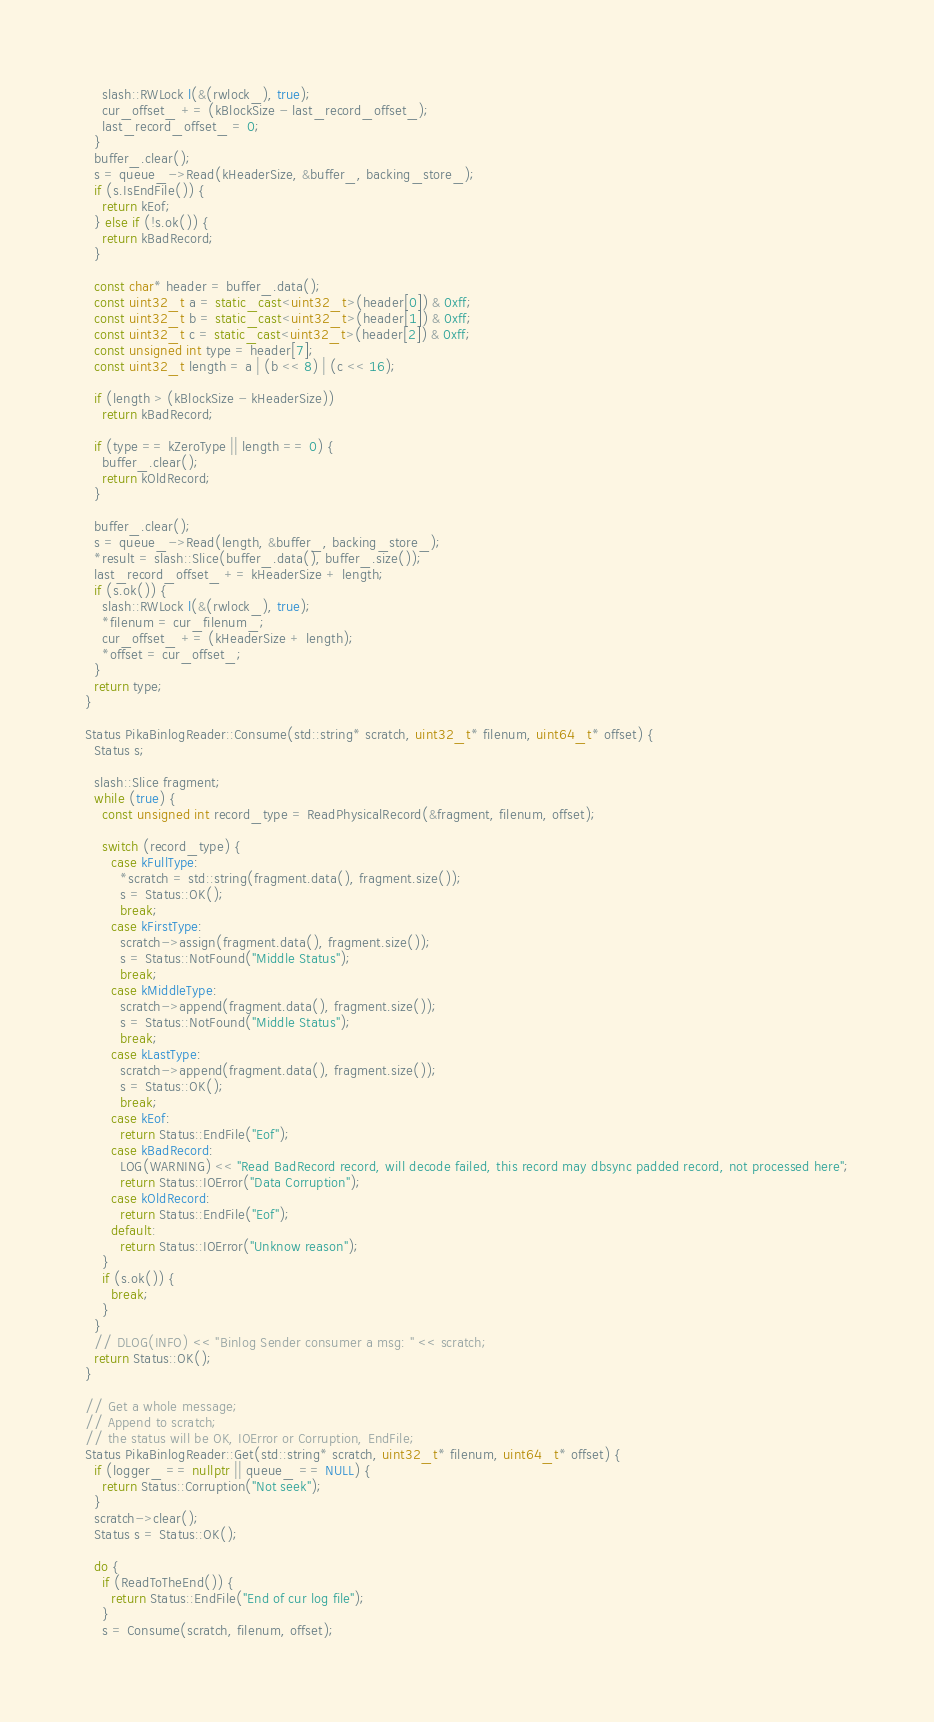<code> <loc_0><loc_0><loc_500><loc_500><_C++_>    slash::RWLock l(&(rwlock_), true);
    cur_offset_ += (kBlockSize - last_record_offset_);
    last_record_offset_ = 0;
  }
  buffer_.clear();
  s = queue_->Read(kHeaderSize, &buffer_, backing_store_);
  if (s.IsEndFile()) {
    return kEof;
  } else if (!s.ok()) {
    return kBadRecord;
  }

  const char* header = buffer_.data();
  const uint32_t a = static_cast<uint32_t>(header[0]) & 0xff;
  const uint32_t b = static_cast<uint32_t>(header[1]) & 0xff;
  const uint32_t c = static_cast<uint32_t>(header[2]) & 0xff;
  const unsigned int type = header[7];
  const uint32_t length = a | (b << 8) | (c << 16);

  if (length > (kBlockSize - kHeaderSize))
    return kBadRecord;

  if (type == kZeroType || length == 0) {
    buffer_.clear();
    return kOldRecord;
  }

  buffer_.clear();
  s = queue_->Read(length, &buffer_, backing_store_);
  *result = slash::Slice(buffer_.data(), buffer_.size());
  last_record_offset_ += kHeaderSize + length;
  if (s.ok()) {
    slash::RWLock l(&(rwlock_), true);
    *filenum = cur_filenum_;
    cur_offset_ += (kHeaderSize + length);
    *offset = cur_offset_;
  }
  return type;
}

Status PikaBinlogReader::Consume(std::string* scratch, uint32_t* filenum, uint64_t* offset) {
  Status s;

  slash::Slice fragment;
  while (true) {
    const unsigned int record_type = ReadPhysicalRecord(&fragment, filenum, offset);

    switch (record_type) {
      case kFullType:
        *scratch = std::string(fragment.data(), fragment.size());
        s = Status::OK();
        break;
      case kFirstType:
        scratch->assign(fragment.data(), fragment.size());
        s = Status::NotFound("Middle Status");
        break;
      case kMiddleType:
        scratch->append(fragment.data(), fragment.size());
        s = Status::NotFound("Middle Status");
        break;
      case kLastType:
        scratch->append(fragment.data(), fragment.size());
        s = Status::OK();
        break;
      case kEof:
        return Status::EndFile("Eof");
      case kBadRecord:
        LOG(WARNING) << "Read BadRecord record, will decode failed, this record may dbsync padded record, not processed here";
        return Status::IOError("Data Corruption");
      case kOldRecord:
        return Status::EndFile("Eof");
      default:
        return Status::IOError("Unknow reason");
    }
    if (s.ok()) {
      break;
    }
  }
  // DLOG(INFO) << "Binlog Sender consumer a msg: " << scratch;
  return Status::OK();
}

// Get a whole message;
// Append to scratch;
// the status will be OK, IOError or Corruption, EndFile;
Status PikaBinlogReader::Get(std::string* scratch, uint32_t* filenum, uint64_t* offset) {
  if (logger_ == nullptr || queue_ == NULL) {
    return Status::Corruption("Not seek");
  }
  scratch->clear();
  Status s = Status::OK();

  do {
    if (ReadToTheEnd()) {
      return Status::EndFile("End of cur log file");
    }
    s = Consume(scratch, filenum, offset);</code> 